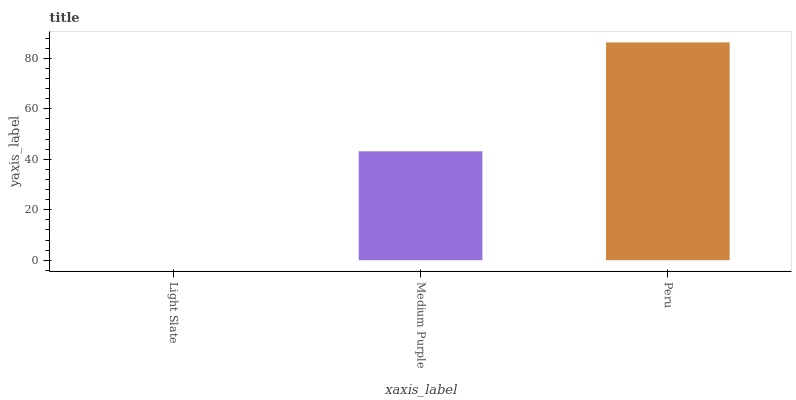Is Light Slate the minimum?
Answer yes or no. Yes. Is Peru the maximum?
Answer yes or no. Yes. Is Medium Purple the minimum?
Answer yes or no. No. Is Medium Purple the maximum?
Answer yes or no. No. Is Medium Purple greater than Light Slate?
Answer yes or no. Yes. Is Light Slate less than Medium Purple?
Answer yes or no. Yes. Is Light Slate greater than Medium Purple?
Answer yes or no. No. Is Medium Purple less than Light Slate?
Answer yes or no. No. Is Medium Purple the high median?
Answer yes or no. Yes. Is Medium Purple the low median?
Answer yes or no. Yes. Is Light Slate the high median?
Answer yes or no. No. Is Peru the low median?
Answer yes or no. No. 